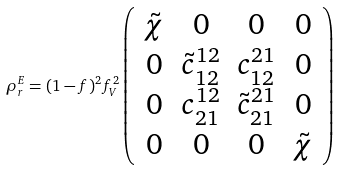<formula> <loc_0><loc_0><loc_500><loc_500>\rho _ { r } ^ { E } = ( 1 - f ) ^ { 2 } f _ { V } ^ { 2 } \left ( \begin{array} { c c c c } \tilde { \chi } & 0 & 0 & 0 \\ 0 & \tilde { c } _ { 1 2 } ^ { 1 2 } & c _ { 1 2 } ^ { 2 1 } & 0 \\ 0 & c _ { 2 1 } ^ { 1 2 } & \tilde { c } _ { 2 1 } ^ { 2 1 } & 0 \\ 0 & 0 & 0 & \tilde { \chi } \end{array} \right )</formula> 